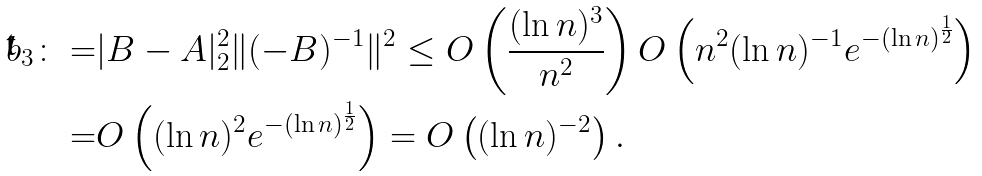<formula> <loc_0><loc_0><loc_500><loc_500>b _ { 3 } \colon = & | B - A | _ { 2 } ^ { 2 } \| ( - B ) ^ { - 1 } \| ^ { 2 } \leq O \left ( \frac { ( \ln n ) ^ { 3 } } { n ^ { 2 } } \right ) O \left ( n ^ { 2 } ( \ln n ) ^ { - 1 } e ^ { - ( \ln n ) ^ { \frac { 1 } { 2 } } } \right ) \\ = & O \left ( { ( \ln n ) ^ { 2 } } e ^ { - ( \ln n ) ^ { \frac { 1 } { 2 } } } \right ) = O \left ( { ( \ln n ) ^ { - 2 } } \right ) .</formula> 